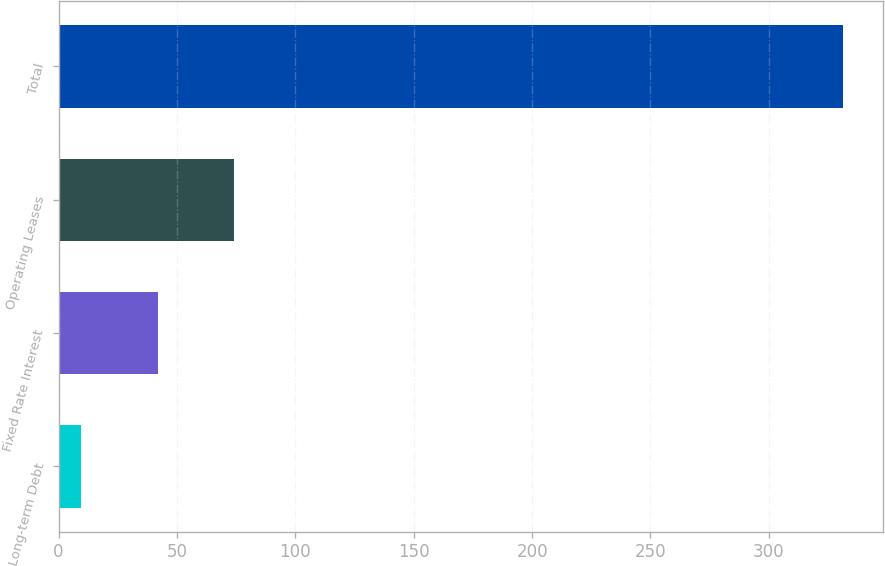<chart> <loc_0><loc_0><loc_500><loc_500><bar_chart><fcel>Long-term Debt<fcel>Fixed Rate Interest<fcel>Operating Leases<fcel>Total<nl><fcel>9.6<fcel>41.79<fcel>73.98<fcel>331.5<nl></chart> 